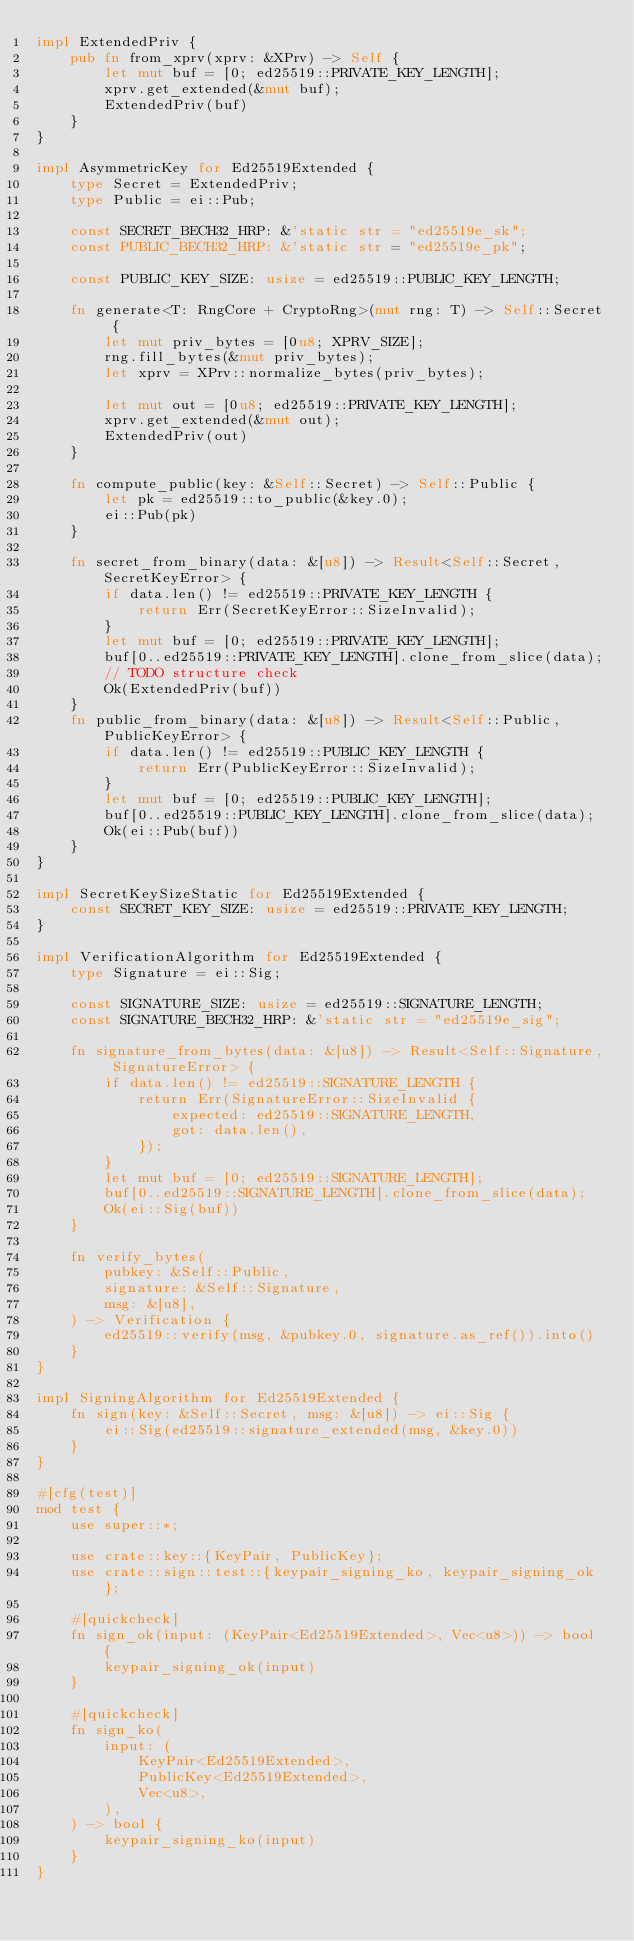Convert code to text. <code><loc_0><loc_0><loc_500><loc_500><_Rust_>impl ExtendedPriv {
    pub fn from_xprv(xprv: &XPrv) -> Self {
        let mut buf = [0; ed25519::PRIVATE_KEY_LENGTH];
        xprv.get_extended(&mut buf);
        ExtendedPriv(buf)
    }
}

impl AsymmetricKey for Ed25519Extended {
    type Secret = ExtendedPriv;
    type Public = ei::Pub;

    const SECRET_BECH32_HRP: &'static str = "ed25519e_sk";
    const PUBLIC_BECH32_HRP: &'static str = "ed25519e_pk";

    const PUBLIC_KEY_SIZE: usize = ed25519::PUBLIC_KEY_LENGTH;

    fn generate<T: RngCore + CryptoRng>(mut rng: T) -> Self::Secret {
        let mut priv_bytes = [0u8; XPRV_SIZE];
        rng.fill_bytes(&mut priv_bytes);
        let xprv = XPrv::normalize_bytes(priv_bytes);

        let mut out = [0u8; ed25519::PRIVATE_KEY_LENGTH];
        xprv.get_extended(&mut out);
        ExtendedPriv(out)
    }

    fn compute_public(key: &Self::Secret) -> Self::Public {
        let pk = ed25519::to_public(&key.0);
        ei::Pub(pk)
    }

    fn secret_from_binary(data: &[u8]) -> Result<Self::Secret, SecretKeyError> {
        if data.len() != ed25519::PRIVATE_KEY_LENGTH {
            return Err(SecretKeyError::SizeInvalid);
        }
        let mut buf = [0; ed25519::PRIVATE_KEY_LENGTH];
        buf[0..ed25519::PRIVATE_KEY_LENGTH].clone_from_slice(data);
        // TODO structure check
        Ok(ExtendedPriv(buf))
    }
    fn public_from_binary(data: &[u8]) -> Result<Self::Public, PublicKeyError> {
        if data.len() != ed25519::PUBLIC_KEY_LENGTH {
            return Err(PublicKeyError::SizeInvalid);
        }
        let mut buf = [0; ed25519::PUBLIC_KEY_LENGTH];
        buf[0..ed25519::PUBLIC_KEY_LENGTH].clone_from_slice(data);
        Ok(ei::Pub(buf))
    }
}

impl SecretKeySizeStatic for Ed25519Extended {
    const SECRET_KEY_SIZE: usize = ed25519::PRIVATE_KEY_LENGTH;
}

impl VerificationAlgorithm for Ed25519Extended {
    type Signature = ei::Sig;

    const SIGNATURE_SIZE: usize = ed25519::SIGNATURE_LENGTH;
    const SIGNATURE_BECH32_HRP: &'static str = "ed25519e_sig";

    fn signature_from_bytes(data: &[u8]) -> Result<Self::Signature, SignatureError> {
        if data.len() != ed25519::SIGNATURE_LENGTH {
            return Err(SignatureError::SizeInvalid {
                expected: ed25519::SIGNATURE_LENGTH,
                got: data.len(),
            });
        }
        let mut buf = [0; ed25519::SIGNATURE_LENGTH];
        buf[0..ed25519::SIGNATURE_LENGTH].clone_from_slice(data);
        Ok(ei::Sig(buf))
    }

    fn verify_bytes(
        pubkey: &Self::Public,
        signature: &Self::Signature,
        msg: &[u8],
    ) -> Verification {
        ed25519::verify(msg, &pubkey.0, signature.as_ref()).into()
    }
}

impl SigningAlgorithm for Ed25519Extended {
    fn sign(key: &Self::Secret, msg: &[u8]) -> ei::Sig {
        ei::Sig(ed25519::signature_extended(msg, &key.0))
    }
}

#[cfg(test)]
mod test {
    use super::*;

    use crate::key::{KeyPair, PublicKey};
    use crate::sign::test::{keypair_signing_ko, keypair_signing_ok};

    #[quickcheck]
    fn sign_ok(input: (KeyPair<Ed25519Extended>, Vec<u8>)) -> bool {
        keypair_signing_ok(input)
    }

    #[quickcheck]
    fn sign_ko(
        input: (
            KeyPair<Ed25519Extended>,
            PublicKey<Ed25519Extended>,
            Vec<u8>,
        ),
    ) -> bool {
        keypair_signing_ko(input)
    }
}
</code> 